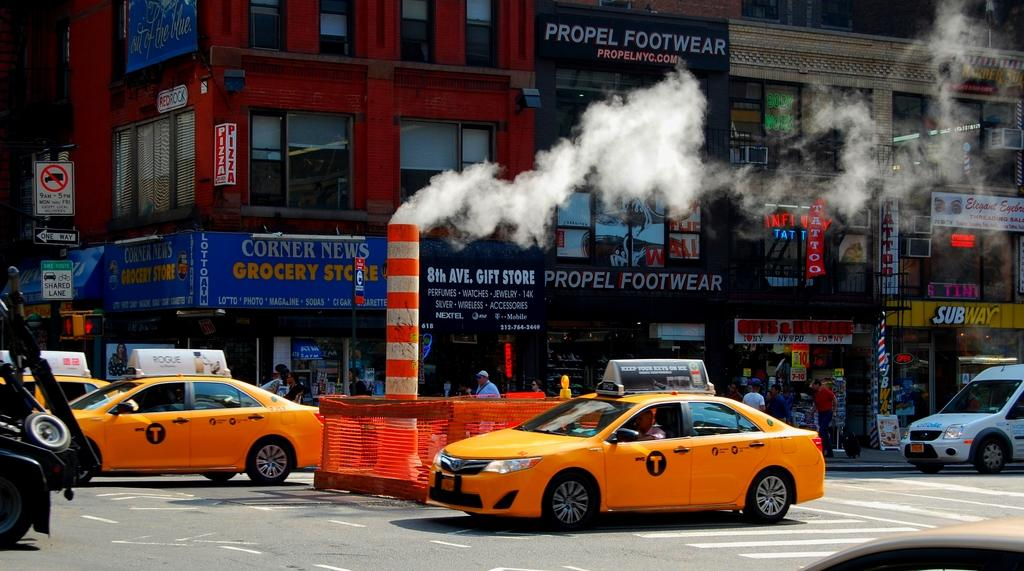<image>
Share a concise interpretation of the image provided. Several tags drive down a street below a corner sign that says Corner news grocery store. 